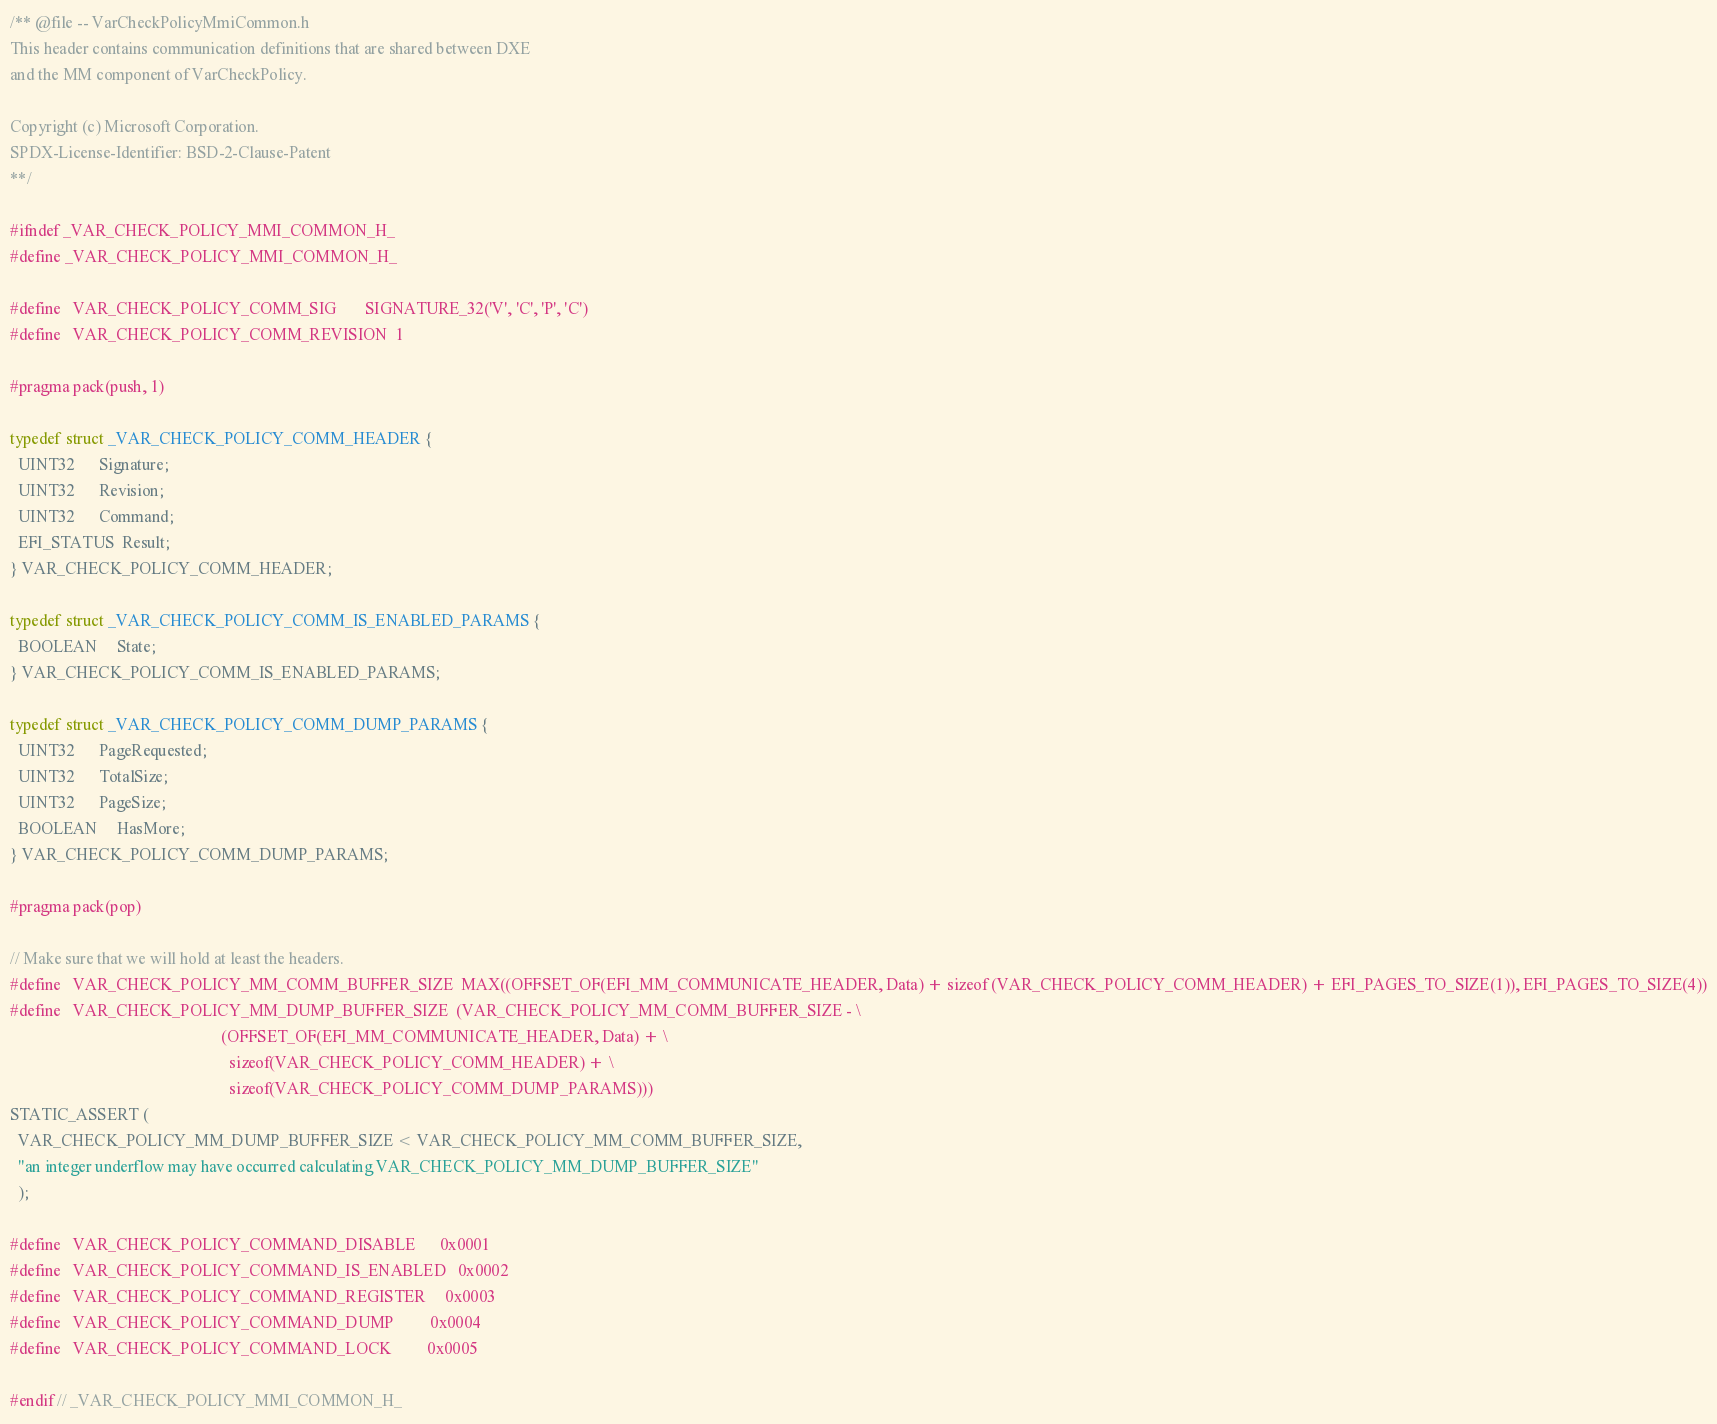Convert code to text. <code><loc_0><loc_0><loc_500><loc_500><_C_>/** @file -- VarCheckPolicyMmiCommon.h
This header contains communication definitions that are shared between DXE
and the MM component of VarCheckPolicy.

Copyright (c) Microsoft Corporation.
SPDX-License-Identifier: BSD-2-Clause-Patent
**/

#ifndef _VAR_CHECK_POLICY_MMI_COMMON_H_
#define _VAR_CHECK_POLICY_MMI_COMMON_H_

#define   VAR_CHECK_POLICY_COMM_SIG       SIGNATURE_32('V', 'C', 'P', 'C')
#define   VAR_CHECK_POLICY_COMM_REVISION  1

#pragma pack(push, 1)

typedef struct _VAR_CHECK_POLICY_COMM_HEADER {
  UINT32      Signature;
  UINT32      Revision;
  UINT32      Command;
  EFI_STATUS  Result;
} VAR_CHECK_POLICY_COMM_HEADER;

typedef struct _VAR_CHECK_POLICY_COMM_IS_ENABLED_PARAMS {
  BOOLEAN     State;
} VAR_CHECK_POLICY_COMM_IS_ENABLED_PARAMS;

typedef struct _VAR_CHECK_POLICY_COMM_DUMP_PARAMS {
  UINT32      PageRequested;
  UINT32      TotalSize;
  UINT32      PageSize;
  BOOLEAN     HasMore;
} VAR_CHECK_POLICY_COMM_DUMP_PARAMS;

#pragma pack(pop)

// Make sure that we will hold at least the headers.
#define   VAR_CHECK_POLICY_MM_COMM_BUFFER_SIZE  MAX((OFFSET_OF(EFI_MM_COMMUNICATE_HEADER, Data) + sizeof (VAR_CHECK_POLICY_COMM_HEADER) + EFI_PAGES_TO_SIZE(1)), EFI_PAGES_TO_SIZE(4))
#define   VAR_CHECK_POLICY_MM_DUMP_BUFFER_SIZE  (VAR_CHECK_POLICY_MM_COMM_BUFFER_SIZE - \
                                                    (OFFSET_OF(EFI_MM_COMMUNICATE_HEADER, Data) + \
                                                      sizeof(VAR_CHECK_POLICY_COMM_HEADER) + \
                                                      sizeof(VAR_CHECK_POLICY_COMM_DUMP_PARAMS)))
STATIC_ASSERT (
  VAR_CHECK_POLICY_MM_DUMP_BUFFER_SIZE < VAR_CHECK_POLICY_MM_COMM_BUFFER_SIZE,
  "an integer underflow may have occurred calculating VAR_CHECK_POLICY_MM_DUMP_BUFFER_SIZE"
  );

#define   VAR_CHECK_POLICY_COMMAND_DISABLE      0x0001
#define   VAR_CHECK_POLICY_COMMAND_IS_ENABLED   0x0002
#define   VAR_CHECK_POLICY_COMMAND_REGISTER     0x0003
#define   VAR_CHECK_POLICY_COMMAND_DUMP         0x0004
#define   VAR_CHECK_POLICY_COMMAND_LOCK         0x0005

#endif // _VAR_CHECK_POLICY_MMI_COMMON_H_
</code> 